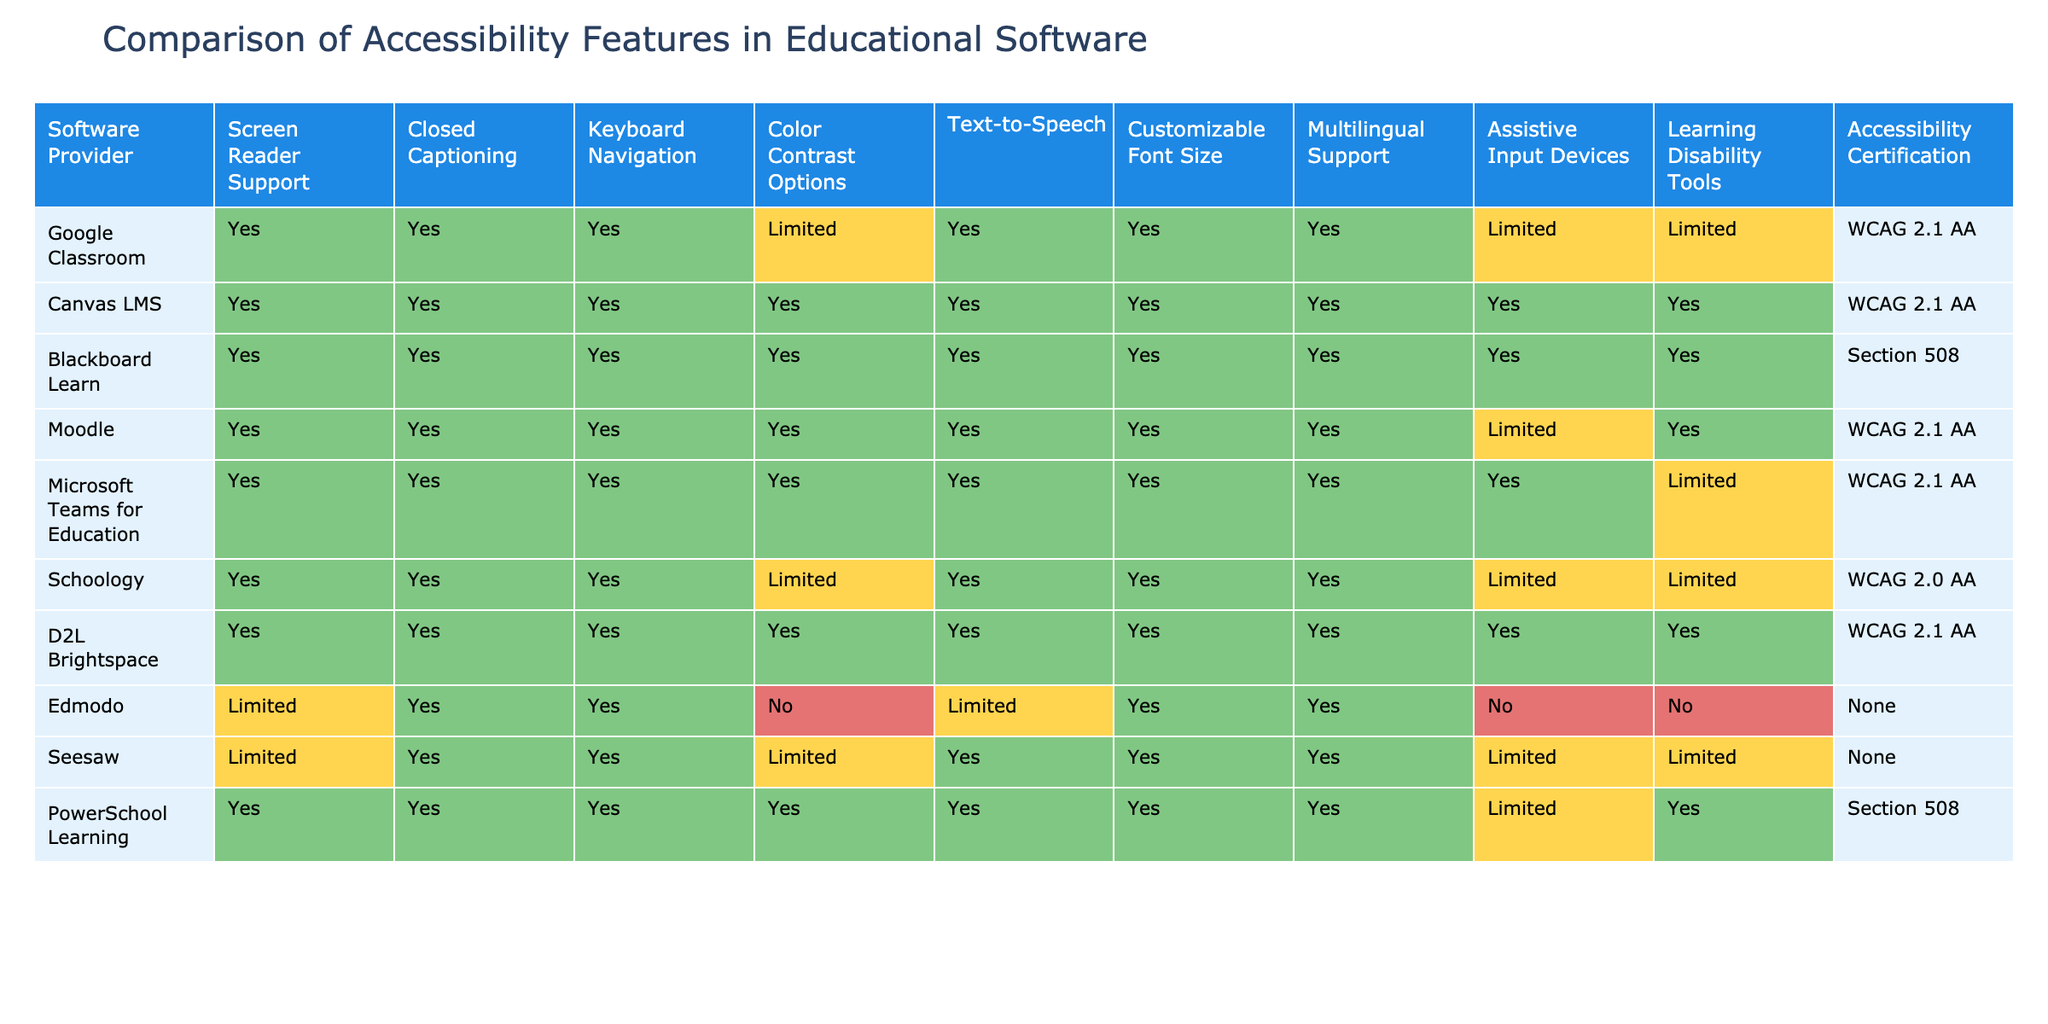What accessibility certification does Blackboard Learn have? The column for Accessibility Certification shows "Section 508" for Blackboard Learn. This information is found directly under the corresponding software provider column in the table.
Answer: Section 508 How many software providers offer customizable font size? Looking at the column for Customizable Font Size, the total number of "Yes" responses, which indicates the number of providers offering this feature, amounts to 7.
Answer: 7 Does Microsoft Teams for Education support assistive input devices? Referring to the Assistive Input Devices column, Microsoft Teams for Education has "Yes" listed, indicating support for this feature.
Answer: Yes Which software has the most accessibility features available? By counting the "Yes" responses for each software across all features, Canvas LMS and D2L Brightspace emerge with 10 "Yes" features each, the highest among the providers.
Answer: Canvas LMS and D2L Brightspace Is closed captioning supported by Edmodo? Checking the Closed Captioning column, Edmodo has a "Yes" response. This means that Edmodo supports closed captioning.
Answer: Yes How many software providers have limited color contrast options? By analyzing the Color Contrast Options column, we see that four providers have "Limited" listed. Therefore, the count of providers with limited color contrast options is 4.
Answer: 4 Which accessibility features does Seesaw lack? Upon reviewing the Seesaw row, we find that it lacks support for color contrast options, text-to-speech, and learning disability tools, as indicated by "Limited" or absence of "Yes."
Answer: Color contrast options, text-to-speech, learning disability tools What percentage of software providers support keyboard navigation? There are 9 software providers listed in the table, and each of them supports keyboard navigation with a "Yes" response. Therefore, the percentage is 100%.
Answer: 100% Are there any providers with no accessibility certification? By examining the Accessibility Certification column, we find that both Edmodo and Seesaw have "None" listed, so they do not possess any accessibility certification.
Answer: Yes Which software provider has the least amount of "Yes" features? After counting the "Yes" features, Edmodo has only 4 "Yes" responses, the least of any provider.
Answer: Edmodo 